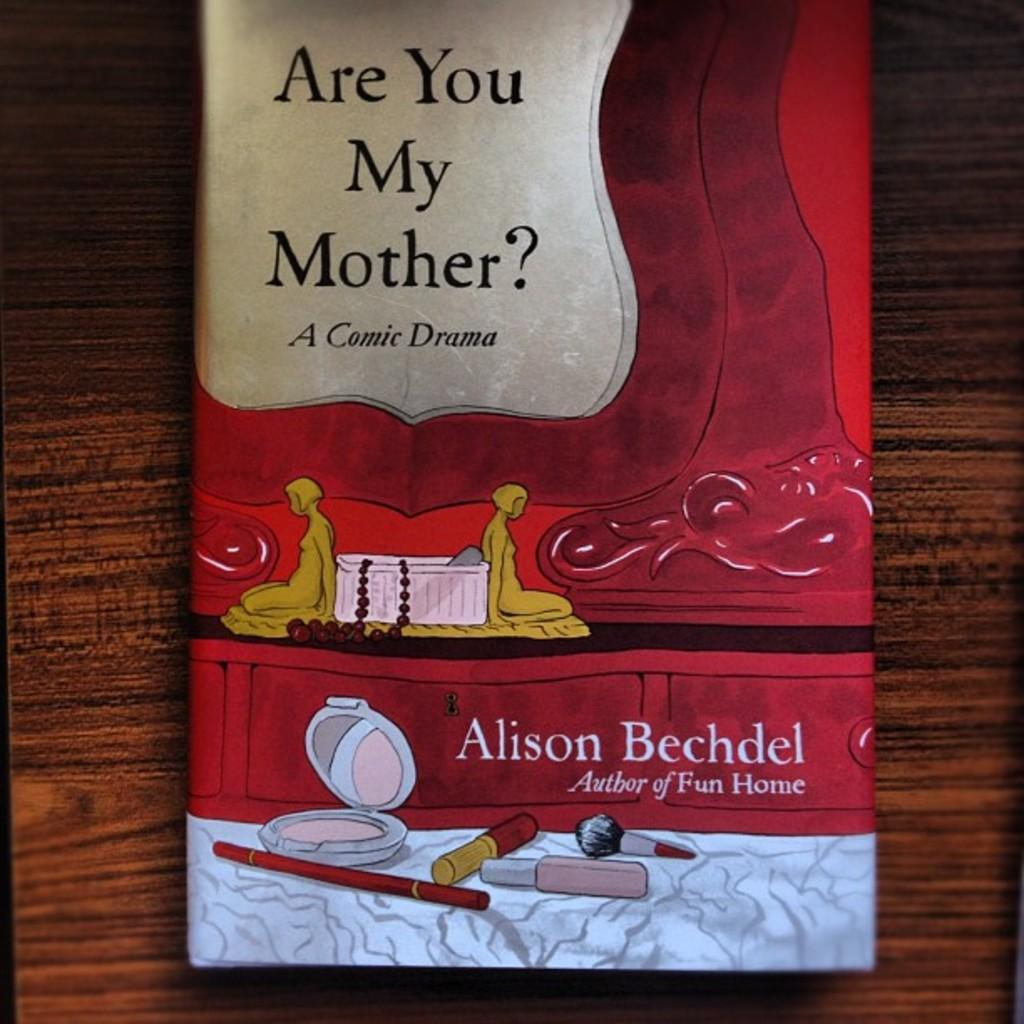Provide a one-sentence caption for the provided image. The book is called are you my mother and it is a comic drama. 